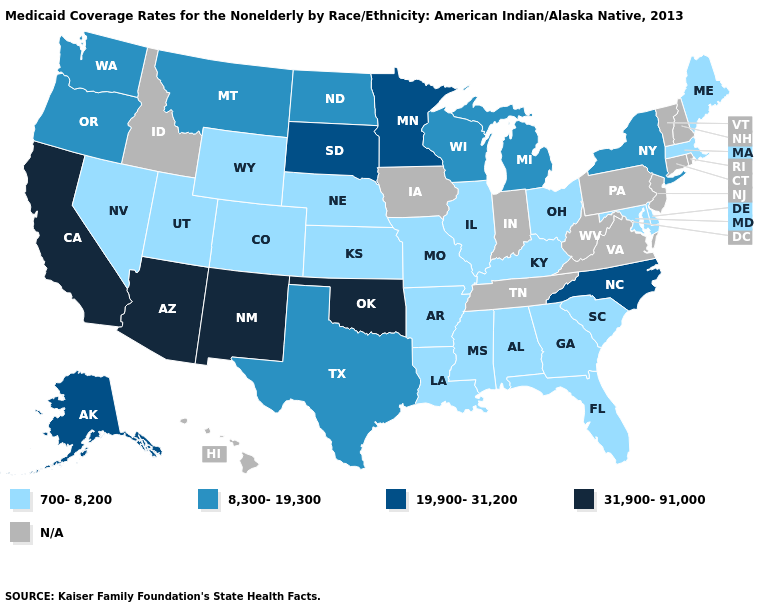Among the states that border Illinois , which have the highest value?
Be succinct. Wisconsin. What is the value of Alabama?
Keep it brief. 700-8,200. What is the value of Massachusetts?
Answer briefly. 700-8,200. What is the value of New York?
Keep it brief. 8,300-19,300. What is the value of South Carolina?
Quick response, please. 700-8,200. What is the highest value in states that border Kentucky?
Be succinct. 700-8,200. Name the states that have a value in the range 700-8,200?
Write a very short answer. Alabama, Arkansas, Colorado, Delaware, Florida, Georgia, Illinois, Kansas, Kentucky, Louisiana, Maine, Maryland, Massachusetts, Mississippi, Missouri, Nebraska, Nevada, Ohio, South Carolina, Utah, Wyoming. Name the states that have a value in the range N/A?
Answer briefly. Connecticut, Hawaii, Idaho, Indiana, Iowa, New Hampshire, New Jersey, Pennsylvania, Rhode Island, Tennessee, Vermont, Virginia, West Virginia. Name the states that have a value in the range N/A?
Be succinct. Connecticut, Hawaii, Idaho, Indiana, Iowa, New Hampshire, New Jersey, Pennsylvania, Rhode Island, Tennessee, Vermont, Virginia, West Virginia. Among the states that border Iowa , does Minnesota have the highest value?
Concise answer only. Yes. Name the states that have a value in the range 19,900-31,200?
Concise answer only. Alaska, Minnesota, North Carolina, South Dakota. What is the highest value in the Northeast ?
Short answer required. 8,300-19,300. 